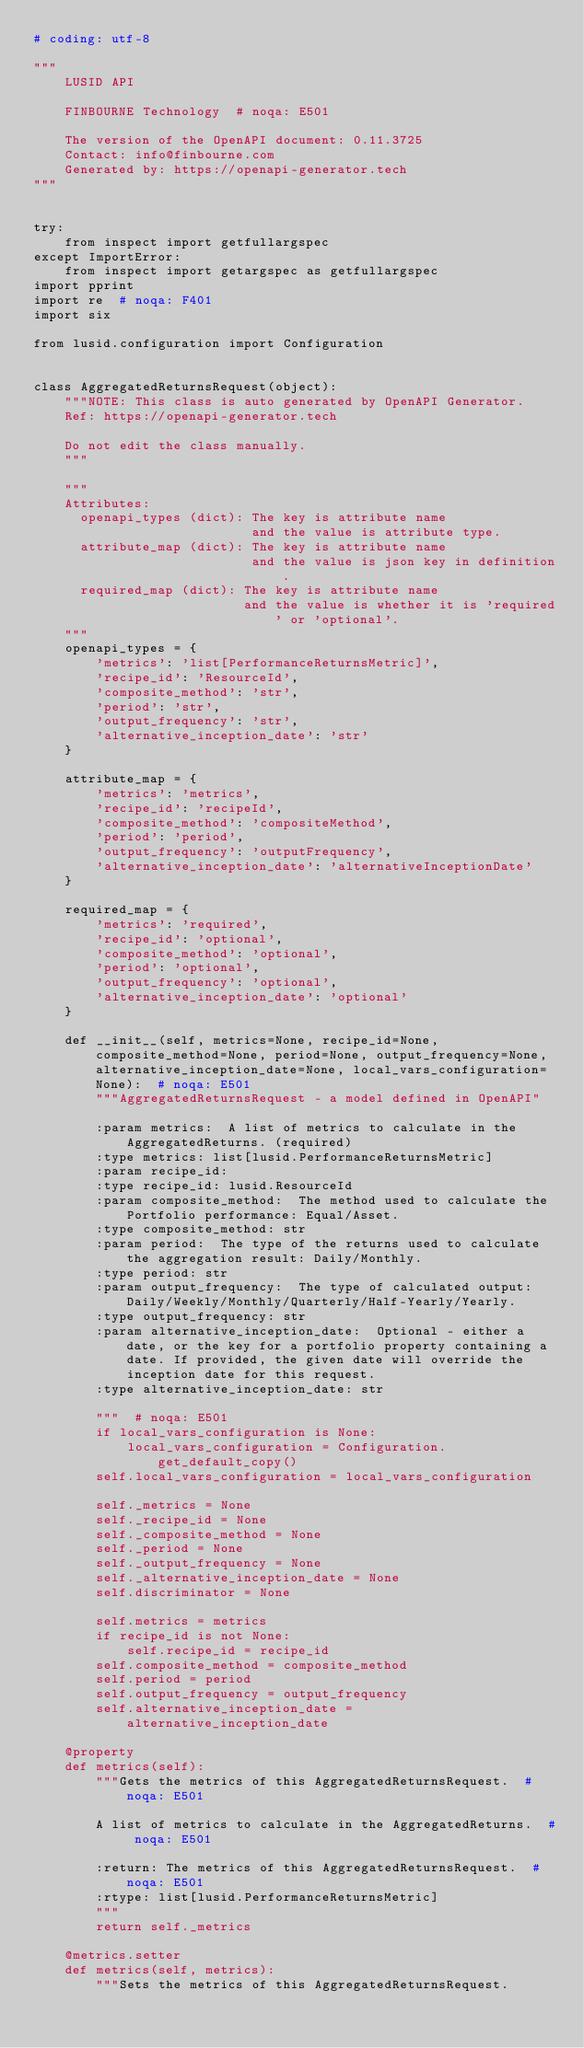<code> <loc_0><loc_0><loc_500><loc_500><_Python_># coding: utf-8

"""
    LUSID API

    FINBOURNE Technology  # noqa: E501

    The version of the OpenAPI document: 0.11.3725
    Contact: info@finbourne.com
    Generated by: https://openapi-generator.tech
"""


try:
    from inspect import getfullargspec
except ImportError:
    from inspect import getargspec as getfullargspec
import pprint
import re  # noqa: F401
import six

from lusid.configuration import Configuration


class AggregatedReturnsRequest(object):
    """NOTE: This class is auto generated by OpenAPI Generator.
    Ref: https://openapi-generator.tech

    Do not edit the class manually.
    """

    """
    Attributes:
      openapi_types (dict): The key is attribute name
                            and the value is attribute type.
      attribute_map (dict): The key is attribute name
                            and the value is json key in definition.
      required_map (dict): The key is attribute name
                           and the value is whether it is 'required' or 'optional'.
    """
    openapi_types = {
        'metrics': 'list[PerformanceReturnsMetric]',
        'recipe_id': 'ResourceId',
        'composite_method': 'str',
        'period': 'str',
        'output_frequency': 'str',
        'alternative_inception_date': 'str'
    }

    attribute_map = {
        'metrics': 'metrics',
        'recipe_id': 'recipeId',
        'composite_method': 'compositeMethod',
        'period': 'period',
        'output_frequency': 'outputFrequency',
        'alternative_inception_date': 'alternativeInceptionDate'
    }

    required_map = {
        'metrics': 'required',
        'recipe_id': 'optional',
        'composite_method': 'optional',
        'period': 'optional',
        'output_frequency': 'optional',
        'alternative_inception_date': 'optional'
    }

    def __init__(self, metrics=None, recipe_id=None, composite_method=None, period=None, output_frequency=None, alternative_inception_date=None, local_vars_configuration=None):  # noqa: E501
        """AggregatedReturnsRequest - a model defined in OpenAPI"
        
        :param metrics:  A list of metrics to calculate in the AggregatedReturns. (required)
        :type metrics: list[lusid.PerformanceReturnsMetric]
        :param recipe_id: 
        :type recipe_id: lusid.ResourceId
        :param composite_method:  The method used to calculate the Portfolio performance: Equal/Asset.
        :type composite_method: str
        :param period:  The type of the returns used to calculate the aggregation result: Daily/Monthly.
        :type period: str
        :param output_frequency:  The type of calculated output: Daily/Weekly/Monthly/Quarterly/Half-Yearly/Yearly.
        :type output_frequency: str
        :param alternative_inception_date:  Optional - either a date, or the key for a portfolio property containing a date. If provided, the given date will override the inception date for this request.
        :type alternative_inception_date: str

        """  # noqa: E501
        if local_vars_configuration is None:
            local_vars_configuration = Configuration.get_default_copy()
        self.local_vars_configuration = local_vars_configuration

        self._metrics = None
        self._recipe_id = None
        self._composite_method = None
        self._period = None
        self._output_frequency = None
        self._alternative_inception_date = None
        self.discriminator = None

        self.metrics = metrics
        if recipe_id is not None:
            self.recipe_id = recipe_id
        self.composite_method = composite_method
        self.period = period
        self.output_frequency = output_frequency
        self.alternative_inception_date = alternative_inception_date

    @property
    def metrics(self):
        """Gets the metrics of this AggregatedReturnsRequest.  # noqa: E501

        A list of metrics to calculate in the AggregatedReturns.  # noqa: E501

        :return: The metrics of this AggregatedReturnsRequest.  # noqa: E501
        :rtype: list[lusid.PerformanceReturnsMetric]
        """
        return self._metrics

    @metrics.setter
    def metrics(self, metrics):
        """Sets the metrics of this AggregatedReturnsRequest.
</code> 